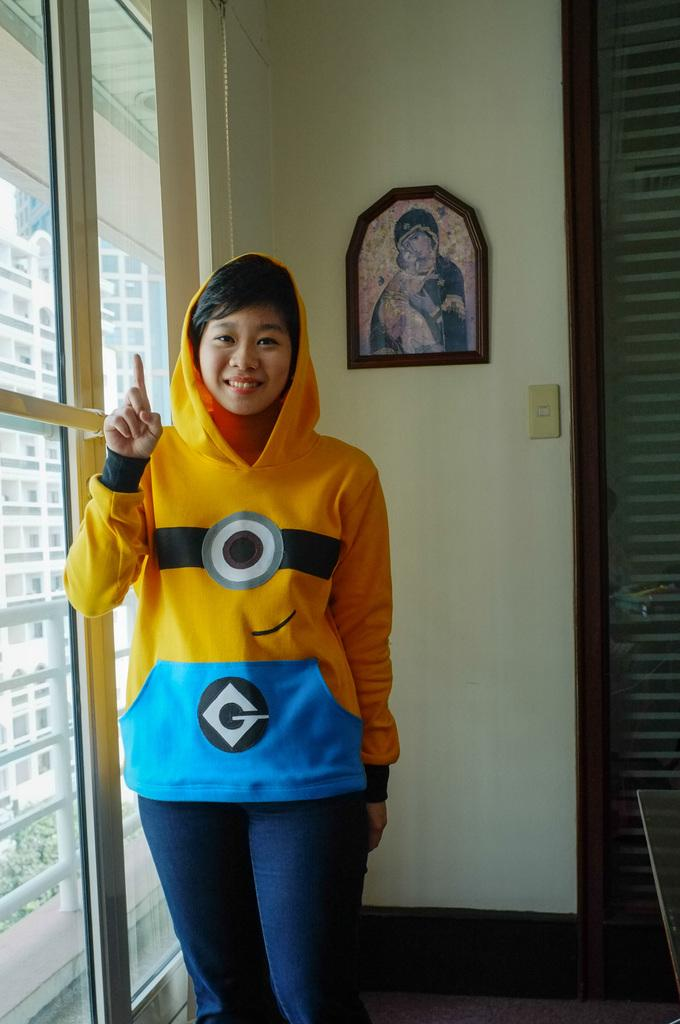What is the main subject of the image? There is a person in the image. What is the person doing in the image? The person is showing their index finger. Where is the person standing in the image? The person is standing beside a glass wall. What can be seen on the wall in the image? There is a photo frame on the wall. What is visible through the glass wall in the image? A view of a building is visible through the glass wall. Can you see any jellyfish swimming in the sea in the image? There is no sea or jellyfish present in the image. 